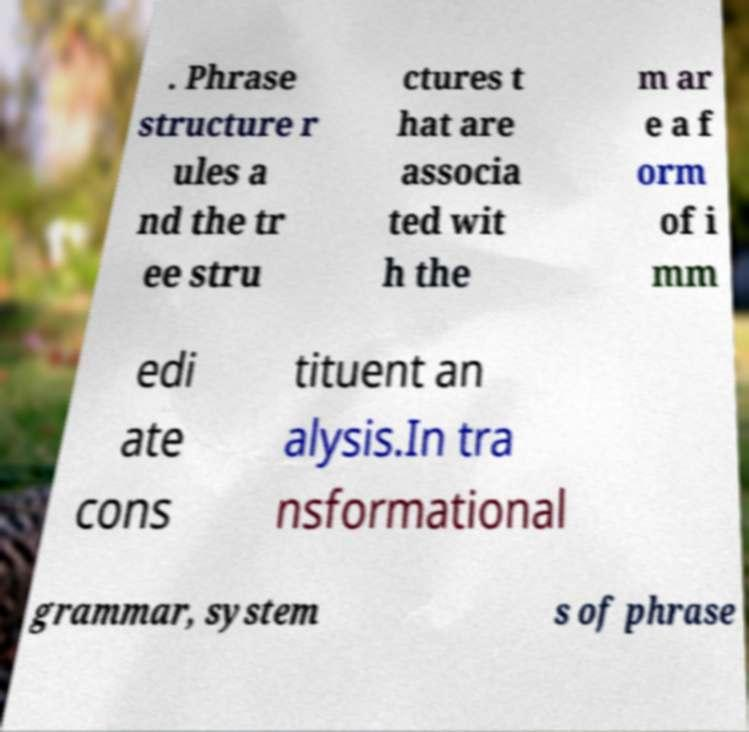Can you accurately transcribe the text from the provided image for me? . Phrase structure r ules a nd the tr ee stru ctures t hat are associa ted wit h the m ar e a f orm of i mm edi ate cons tituent an alysis.In tra nsformational grammar, system s of phrase 